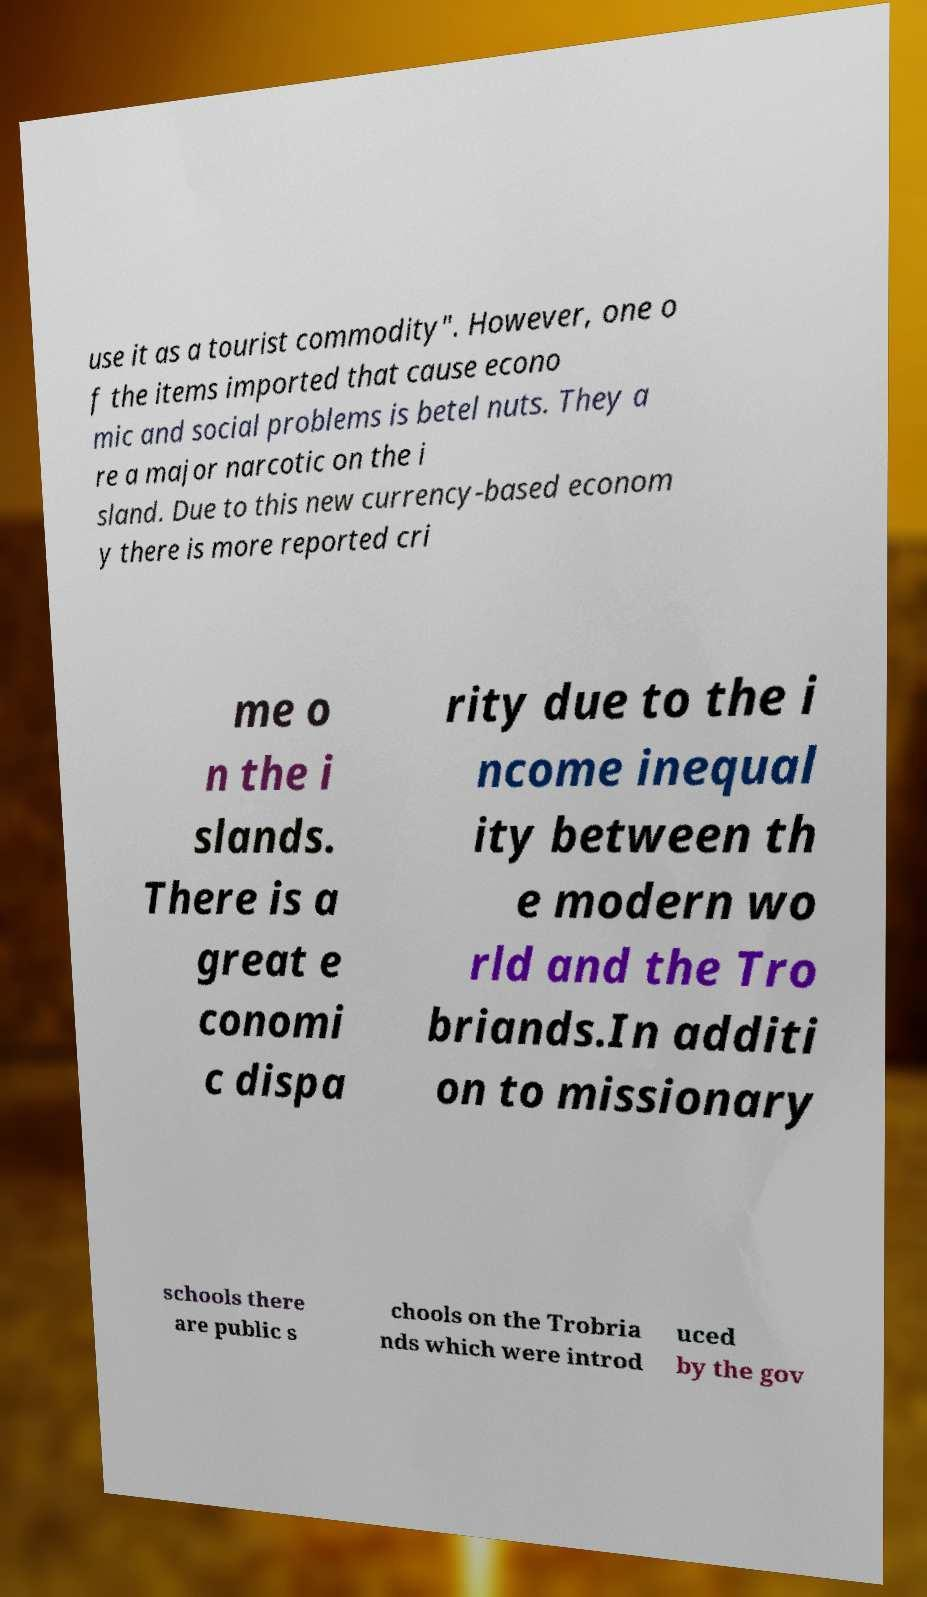Can you read and provide the text displayed in the image?This photo seems to have some interesting text. Can you extract and type it out for me? use it as a tourist commodity". However, one o f the items imported that cause econo mic and social problems is betel nuts. They a re a major narcotic on the i sland. Due to this new currency-based econom y there is more reported cri me o n the i slands. There is a great e conomi c dispa rity due to the i ncome inequal ity between th e modern wo rld and the Tro briands.In additi on to missionary schools there are public s chools on the Trobria nds which were introd uced by the gov 